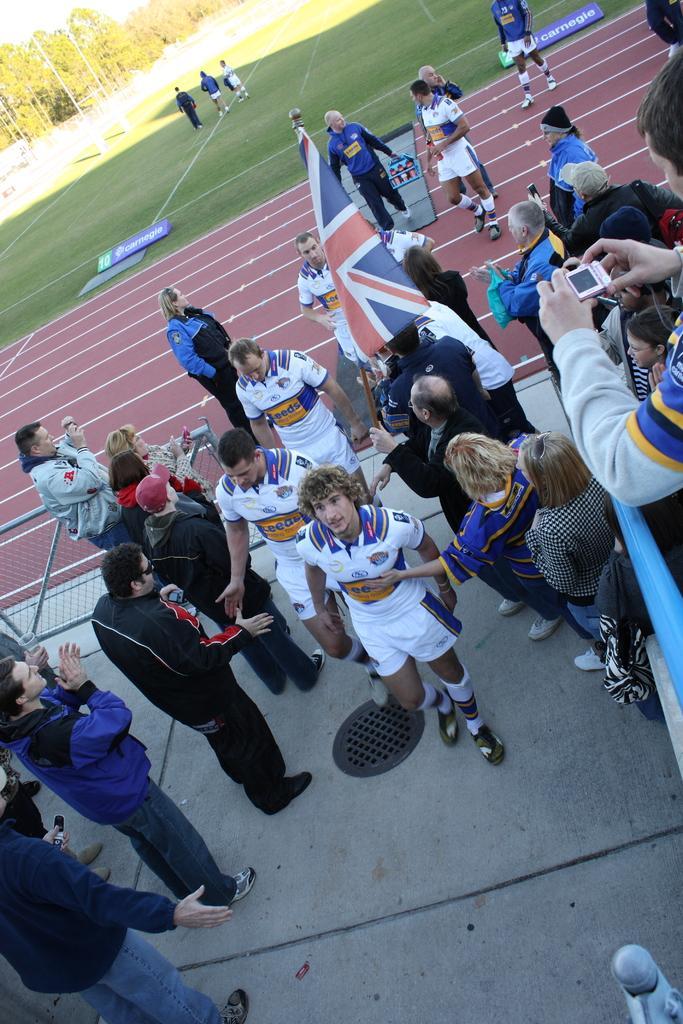In one or two sentences, can you explain what this image depicts? This image is taken outdoors. At the bottom of the image there is a floor. In the background there are many trees. There are few poles. There is a ground with grass on it. A few people are walking on the ground. In the middle of the image many people are walking on the floor and a few are standing. There is a flag. 